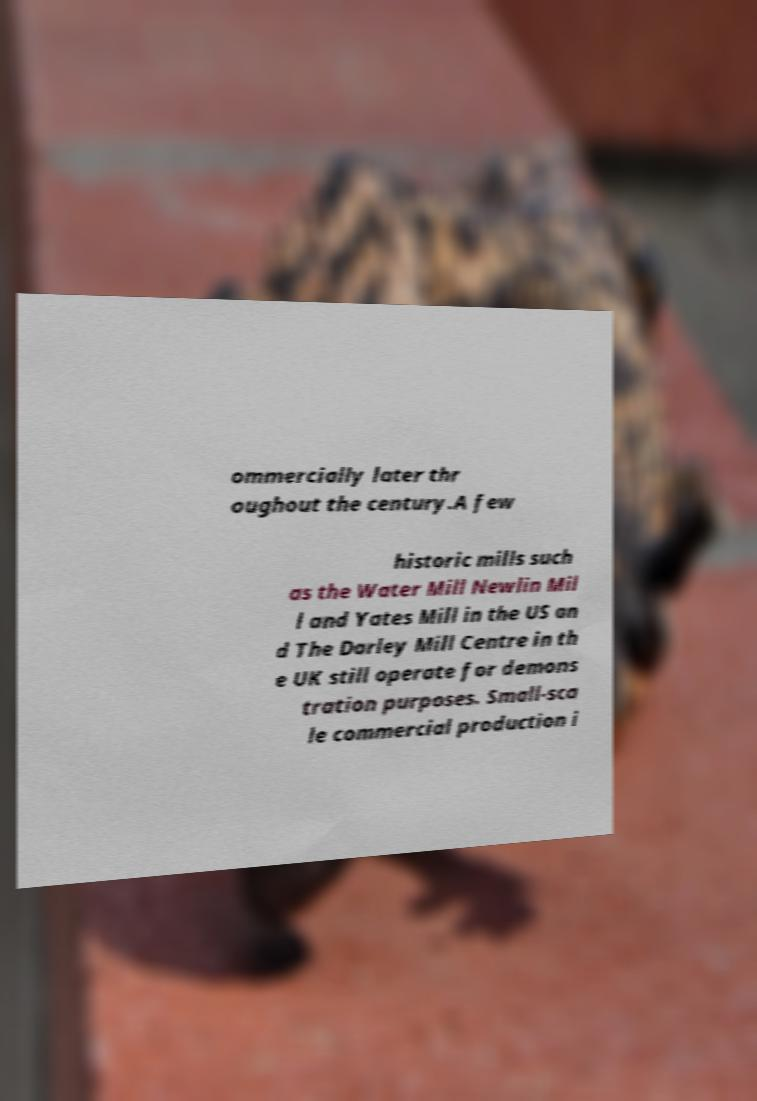For documentation purposes, I need the text within this image transcribed. Could you provide that? ommercially later thr oughout the century.A few historic mills such as the Water Mill Newlin Mil l and Yates Mill in the US an d The Darley Mill Centre in th e UK still operate for demons tration purposes. Small-sca le commercial production i 